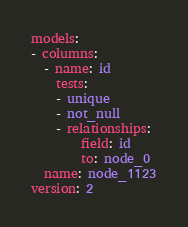Convert code to text. <code><loc_0><loc_0><loc_500><loc_500><_YAML_>models:
- columns:
  - name: id
    tests:
    - unique
    - not_null
    - relationships:
        field: id
        to: node_0
  name: node_1123
version: 2
</code> 